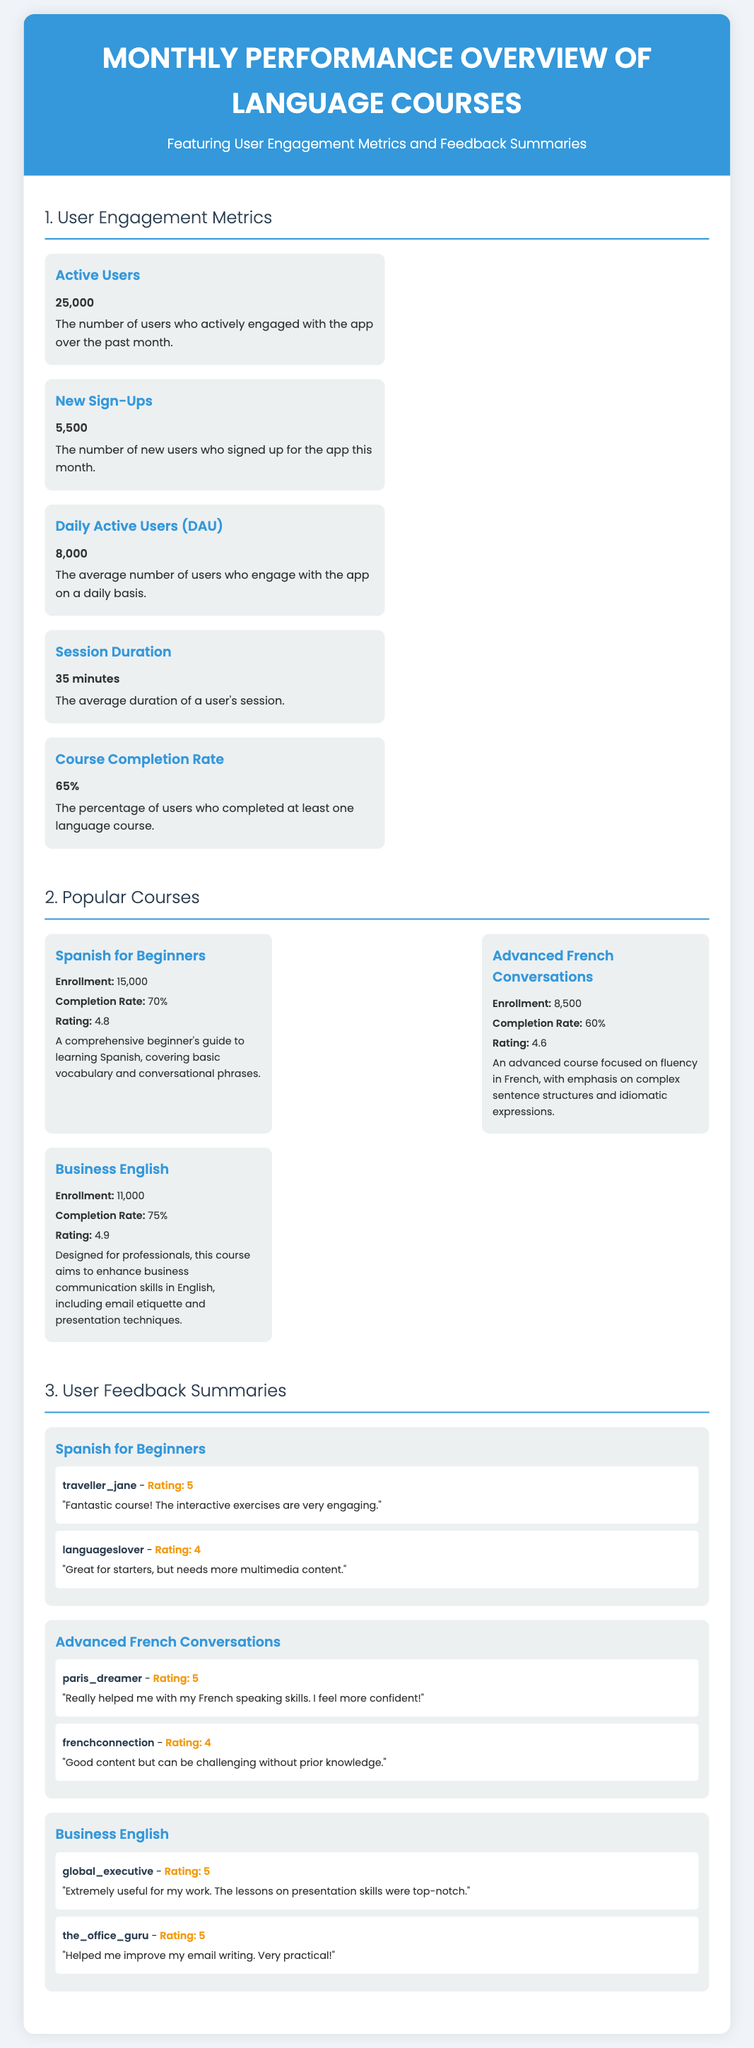What is the total number of active users? The total number of active users is explicitly stated in the document.
Answer: 25,000 What is the completion rate for the Business English course? The completion rate for the Business English course is provided in the details for that course.
Answer: 75% How many new sign-ups were recorded this month? The document specifies the number of new sign-ups for the month.
Answer: 5,500 What is the average session duration? The average session duration is highlighted in the user engagement metrics section.
Answer: 35 minutes Which course has the highest enrollment? The course with the highest enrollment is listed among the popular courses.
Answer: Spanish for Beginners What is the rating for Advanced French Conversations? The rating of the Advanced French Conversations course is mentioned in the feedback summaries.
Answer: 4.6 How many daily active users were reported? The document states the average number of daily active users.
Answer: 8,000 What type of feedback did "traveller_jane" provide for Spanish for Beginners? The feedback from "traveller_jane" is explained in the user feedback summaries.
Answer: "Fantastic course! The interactive exercises are very engaging." Which course targets professionals? The document identifies which course is designed for professionals in the popular courses section.
Answer: Business English 